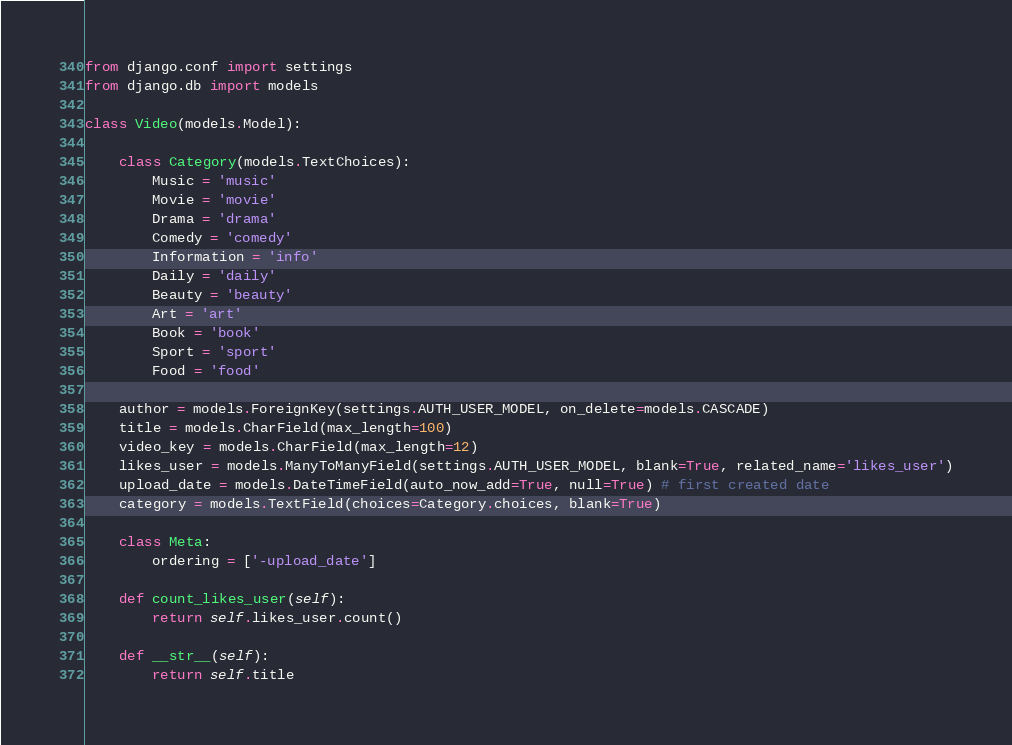Convert code to text. <code><loc_0><loc_0><loc_500><loc_500><_Python_>from django.conf import settings
from django.db import models

class Video(models.Model):

    class Category(models.TextChoices):
        Music = 'music'
        Movie = 'movie'
        Drama = 'drama'
        Comedy = 'comedy'
        Information = 'info'
        Daily = 'daily'
        Beauty = 'beauty'
        Art = 'art'
        Book = 'book'
        Sport = 'sport'
        Food = 'food'

    author = models.ForeignKey(settings.AUTH_USER_MODEL, on_delete=models.CASCADE)
    title = models.CharField(max_length=100)
    video_key = models.CharField(max_length=12)
    likes_user = models.ManyToManyField(settings.AUTH_USER_MODEL, blank=True, related_name='likes_user')
    upload_date = models.DateTimeField(auto_now_add=True, null=True) # first created date
    category = models.TextField(choices=Category.choices, blank=True)

    class Meta:
        ordering = ['-upload_date']

    def count_likes_user(self):
        return self.likes_user.count()

    def __str__(self):
        return self.title
</code> 